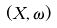<formula> <loc_0><loc_0><loc_500><loc_500>( X , \omega )</formula> 